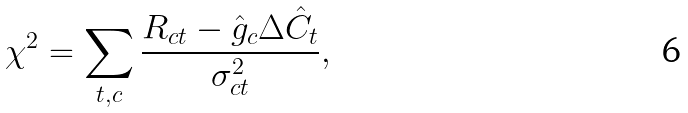Convert formula to latex. <formula><loc_0><loc_0><loc_500><loc_500>\chi ^ { 2 } = \sum _ { t , c } \frac { R _ { c t } - \hat { g } _ { c } \Delta \hat { C } _ { t } } { \sigma ^ { 2 } _ { c t } } ,</formula> 